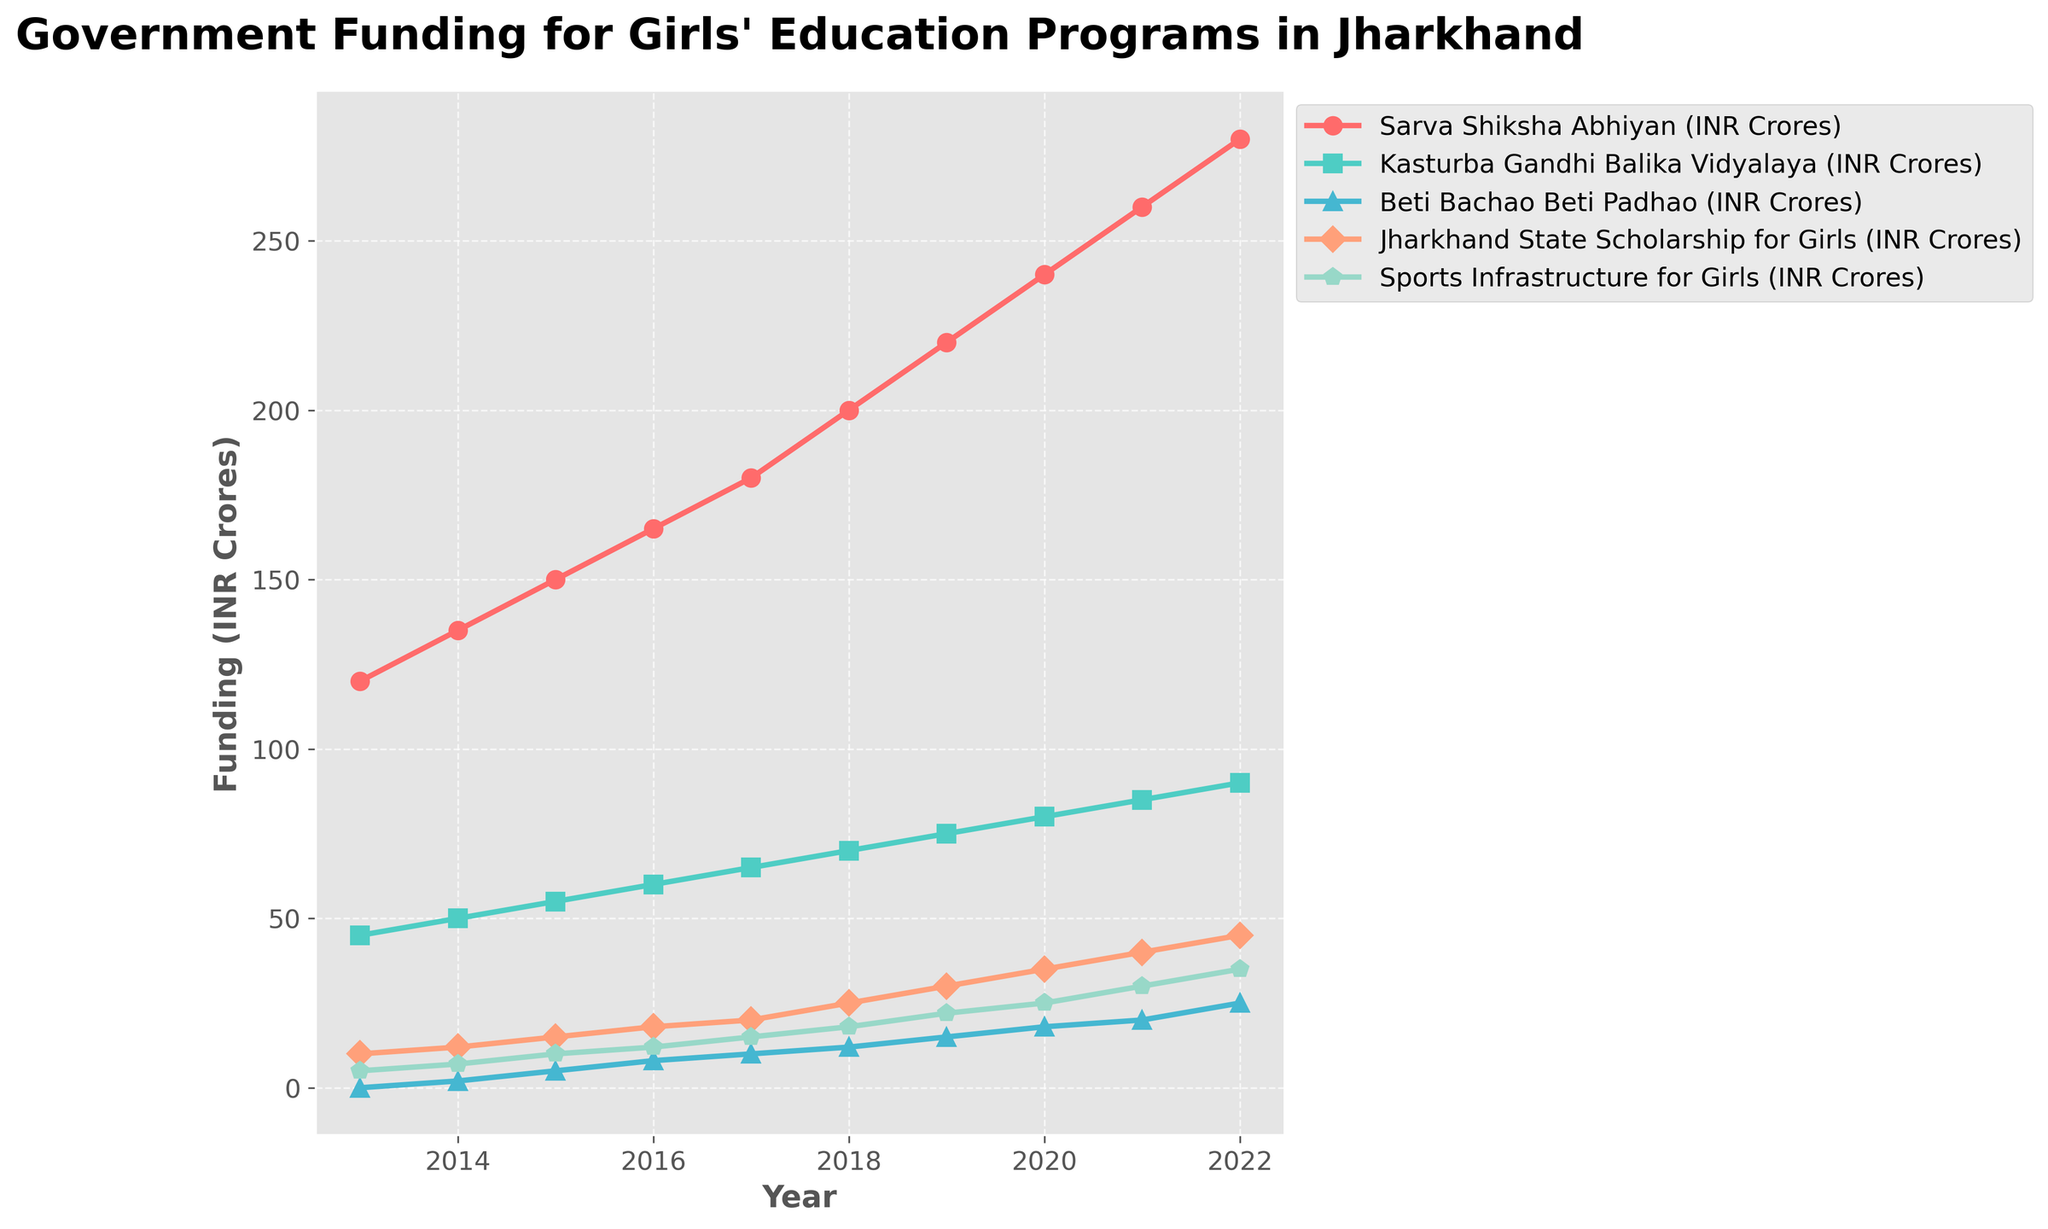What is the amount of funding allocated to the Sarva Shiksha Abhiyan program in 2017? Look at the line corresponding to Sarva Shiksha Abhiyan and find the value for the year 2017.
Answer: 180 INR Crores Which program saw the highest increase in funding from 2013 to 2022? Compare the funding for the year 2013 and 2022 for all programs. The program with the highest difference is the one with the highest increase.
Answer: Sarva Shiksha Abhiyan What is the total funding allocated to Beti Bachao Beti Padhao in all the years combined? Sum the funding values for Beti Bachao Beti Padhao from 2013 to 2022.
Answer: 115 INR Crores Which year witnessed the maximum funding for the Kasturba Gandhi Balika Vidyalaya program? Identify the peak point in the Kasturba Gandhi Balika Vidyalaya line.
Answer: 2022 How much more funding was allocated to Sports Infrastructure for Girls in 2022 compared to 2013? Subtract the 2013 funding amount for Sports Infrastructure for Girls from the 2022 amount.
Answer: 30 INR Crores What trend do you observe in the funding for Jharkhand State Scholarship for Girls over the decade? Examine the line for Jharkhand State Scholarship for Girls and describe the overall pattern.
Answer: Increasing Which program had the smallest funding allocation in 2014? Compare the funding levels for all programs in 2014 and identify the lowest one.
Answer: Beti Bachao Beti Padhao What is the average yearly funding for Kasturba Gandhi Balika Vidyalaya over the decade? Sum the yearly funding amounts for Kasturba Gandhi Balika Vidyalaya and divide by the number of years (10).
Answer: 67.5 INR Crores Compare the funding trend for Sarva Shiksha Abhiyan and Beti Bachao Beti Padhao. Which program saw a steadier increase? Evaluate the slopes of the lines representing Sarva Shiksha Abhiyan and Beti Bachao Beti Padhao to determine which had a steadier increase.
Answer: Sarva Shiksha Abhiyan What is the average difference in funding between the highest and lowest funded years for Jharkhand State Scholarship for Girls? Find the maximum and minimum funding amounts for Jharkhand State Scholarship for Girls, compute the difference, and obtain the average difference per year by dividing by the number of years (10).
Answer: 35 INR Crores 